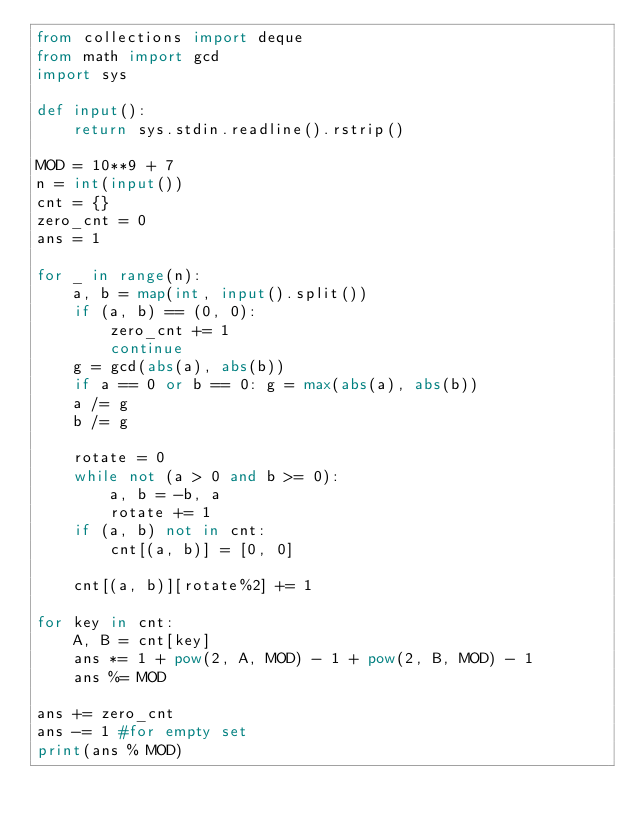<code> <loc_0><loc_0><loc_500><loc_500><_Python_>from collections import deque
from math import gcd
import sys

def input():
    return sys.stdin.readline().rstrip()

MOD = 10**9 + 7
n = int(input())
cnt = {}
zero_cnt = 0
ans = 1

for _ in range(n):
    a, b = map(int, input().split())
    if (a, b) == (0, 0):
        zero_cnt += 1
        continue
    g = gcd(abs(a), abs(b))
    if a == 0 or b == 0: g = max(abs(a), abs(b))
    a /= g
    b /= g

    rotate = 0
    while not (a > 0 and b >= 0):
        a, b = -b, a
        rotate += 1
    if (a, b) not in cnt:
        cnt[(a, b)] = [0, 0]

    cnt[(a, b)][rotate%2] += 1

for key in cnt:
    A, B = cnt[key]
    ans *= 1 + pow(2, A, MOD) - 1 + pow(2, B, MOD) - 1
    ans %= MOD

ans += zero_cnt
ans -= 1 #for empty set
print(ans % MOD)
</code> 